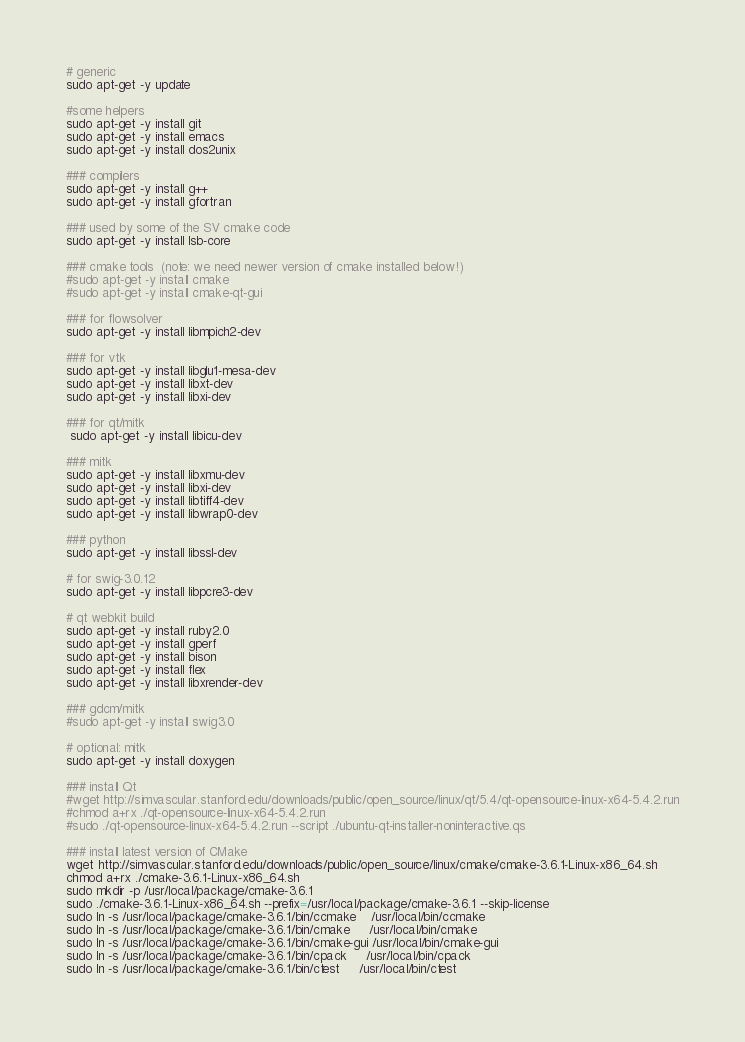Convert code to text. <code><loc_0><loc_0><loc_500><loc_500><_Bash_># generic
sudo apt-get -y update

#some helpers
sudo apt-get -y install git
sudo apt-get -y install emacs
sudo apt-get -y install dos2unix

### compilers
sudo apt-get -y install g++
sudo apt-get -y install gfortran

### used by some of the SV cmake code
sudo apt-get -y install lsb-core

### cmake tools  (note: we need newer version of cmake installed below!)
#sudo apt-get -y install cmake
#sudo apt-get -y install cmake-qt-gui

### for flowsolver
sudo apt-get -y install libmpich2-dev

### for vtk
sudo apt-get -y install libglu1-mesa-dev
sudo apt-get -y install libxt-dev
sudo apt-get -y install libxi-dev

### for qt/mitk
 sudo apt-get -y install libicu-dev

### mitk
sudo apt-get -y install libxmu-dev
sudo apt-get -y install libxi-dev
sudo apt-get -y install libtiff4-dev
sudo apt-get -y install libwrap0-dev

### python
sudo apt-get -y install libssl-dev

# for swig-3.0.12
sudo apt-get -y install libpcre3-dev

# qt webkit build
sudo apt-get -y install ruby2.0
sudo apt-get -y install gperf
sudo apt-get -y install bison
sudo apt-get -y install flex
sudo apt-get -y install libxrender-dev

### gdcm/mitk
#sudo apt-get -y install swig3.0

# optional: mitk
sudo apt-get -y install doxygen

### install Qt
#wget http://simvascular.stanford.edu/downloads/public/open_source/linux/qt/5.4/qt-opensource-linux-x64-5.4.2.run
#chmod a+rx ./qt-opensource-linux-x64-5.4.2.run
#sudo ./qt-opensource-linux-x64-5.4.2.run --script ./ubuntu-qt-installer-noninteractive.qs

### install latest version of CMake
wget http://simvascular.stanford.edu/downloads/public/open_source/linux/cmake/cmake-3.6.1-Linux-x86_64.sh
chmod a+rx ./cmake-3.6.1-Linux-x86_64.sh
sudo mkdir -p /usr/local/package/cmake-3.6.1
sudo ./cmake-3.6.1-Linux-x86_64.sh --prefix=/usr/local/package/cmake-3.6.1 --skip-license
sudo ln -s /usr/local/package/cmake-3.6.1/bin/ccmake    /usr/local/bin/ccmake
sudo ln -s /usr/local/package/cmake-3.6.1/bin/cmake     /usr/local/bin/cmake
sudo ln -s /usr/local/package/cmake-3.6.1/bin/cmake-gui /usr/local/bin/cmake-gui
sudo ln -s /usr/local/package/cmake-3.6.1/bin/cpack     /usr/local/bin/cpack
sudo ln -s /usr/local/package/cmake-3.6.1/bin/ctest     /usr/local/bin/ctest
</code> 